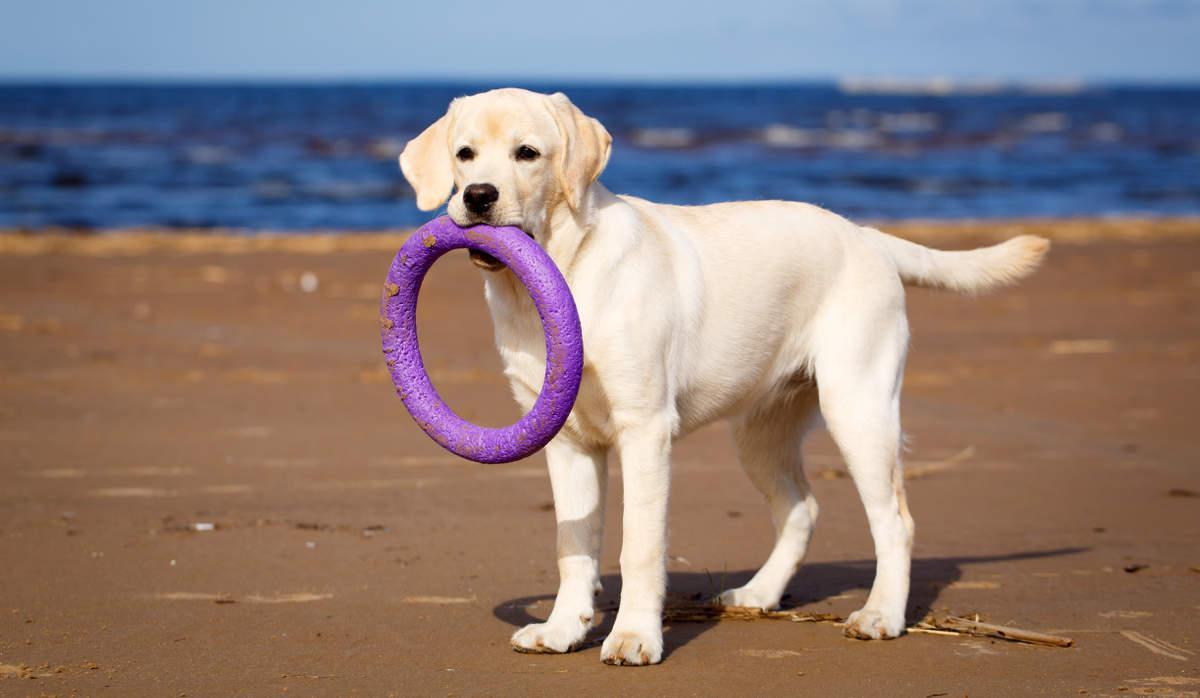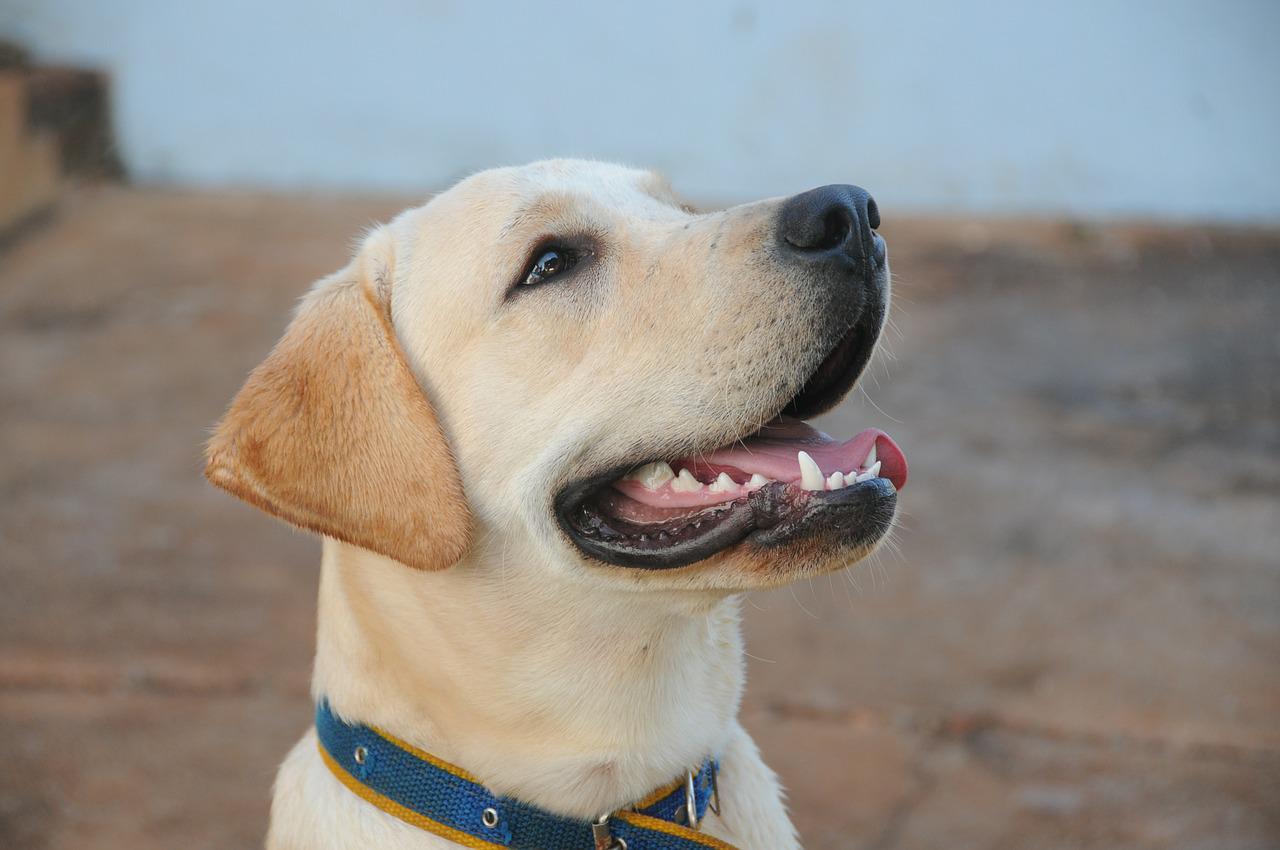The first image is the image on the left, the second image is the image on the right. Evaluate the accuracy of this statement regarding the images: "There is a dog sitting on a grassy lawn". Is it true? Answer yes or no. No. The first image is the image on the left, the second image is the image on the right. Assess this claim about the two images: "No dogs have dark fur, one dog is standing on all fours, and at least one dog wears a collar.". Correct or not? Answer yes or no. Yes. 